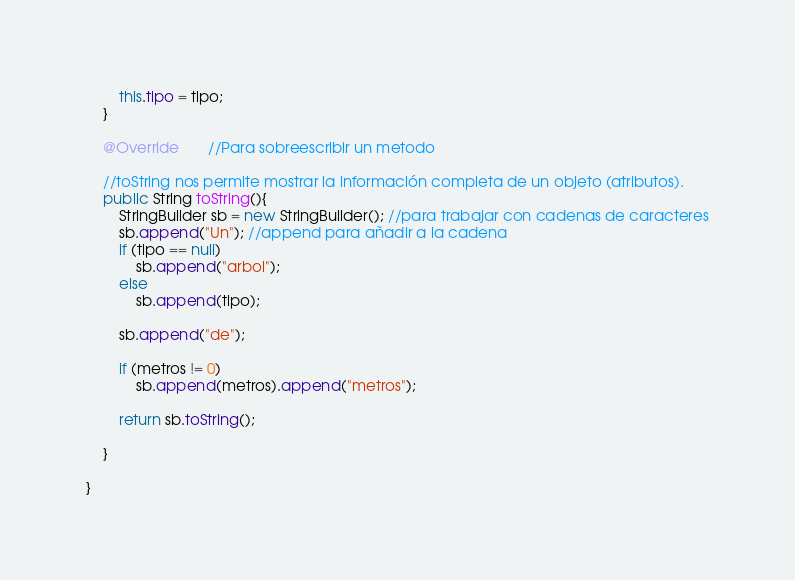<code> <loc_0><loc_0><loc_500><loc_500><_Java_>        this.tipo = tipo;
    }

    @Override       //Para sobreescribir un metodo

    //toString nos permite mostrar la información completa de un objeto (atributos).
    public String toString(){
        StringBuilder sb = new StringBuilder(); //para trabajar con cadenas de caracteres
        sb.append("Un"); //append para añadir a la cadena
        if (tipo == null)
            sb.append("arbol");
        else
            sb.append(tipo);

        sb.append("de");

        if (metros != 0)
            sb.append(metros).append("metros");

        return sb.toString();

    }

}
</code> 